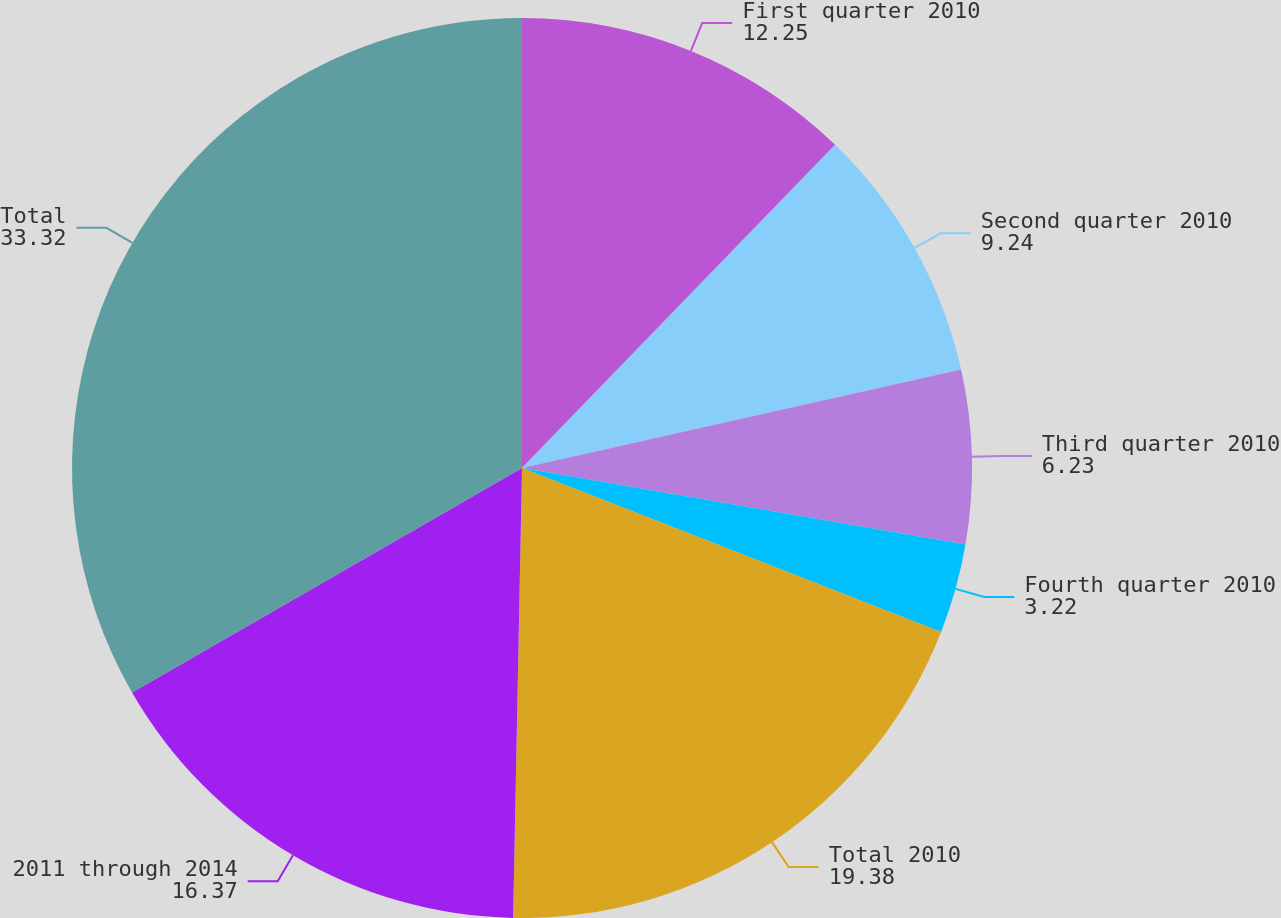Convert chart to OTSL. <chart><loc_0><loc_0><loc_500><loc_500><pie_chart><fcel>First quarter 2010<fcel>Second quarter 2010<fcel>Third quarter 2010<fcel>Fourth quarter 2010<fcel>Total 2010<fcel>2011 through 2014<fcel>Total<nl><fcel>12.25%<fcel>9.24%<fcel>6.23%<fcel>3.22%<fcel>19.38%<fcel>16.37%<fcel>33.32%<nl></chart> 